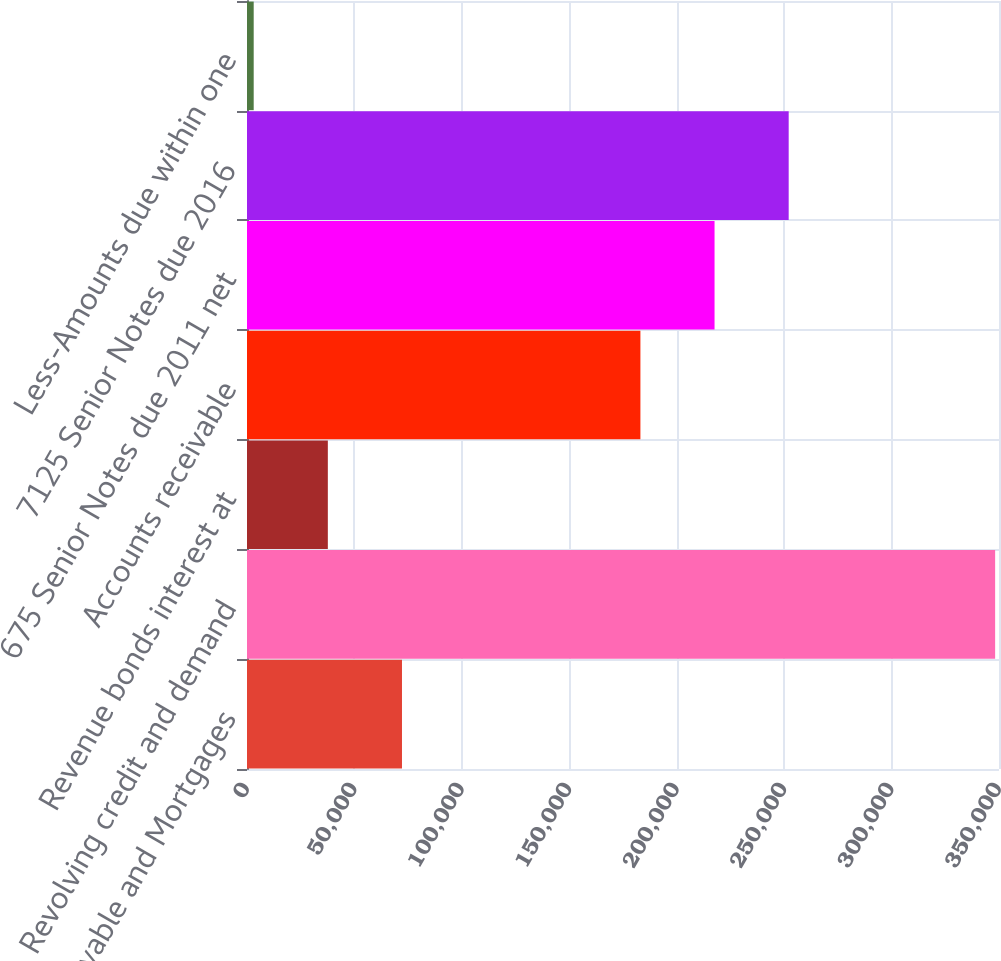<chart> <loc_0><loc_0><loc_500><loc_500><bar_chart><fcel>Notes payable and Mortgages<fcel>Revolving credit and demand<fcel>Revenue bonds interest at<fcel>Accounts receivable<fcel>675 Senior Notes due 2011 net<fcel>7125 Senior Notes due 2016<fcel>Less-Amounts due within one<nl><fcel>72132.8<fcel>348200<fcel>37624.4<fcel>183100<fcel>217608<fcel>252117<fcel>3116<nl></chart> 